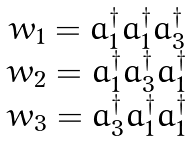Convert formula to latex. <formula><loc_0><loc_0><loc_500><loc_500>\begin{array} { c } w _ { 1 } = a ^ { \dagger } _ { 1 } a ^ { \dagger } _ { 1 } a ^ { \dagger } _ { 3 } \\ w _ { 2 } = a ^ { \dagger } _ { 1 } a ^ { \dagger } _ { 3 } a ^ { \dagger } _ { 1 } \\ w _ { 3 } = a ^ { \dagger } _ { 3 } a ^ { \dagger } _ { 1 } a ^ { \dagger } _ { 1 } \end{array}</formula> 